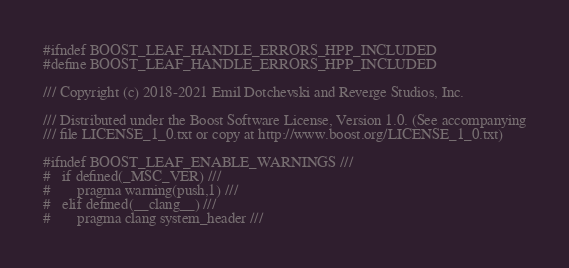Convert code to text. <code><loc_0><loc_0><loc_500><loc_500><_C++_>#ifndef BOOST_LEAF_HANDLE_ERRORS_HPP_INCLUDED
#define BOOST_LEAF_HANDLE_ERRORS_HPP_INCLUDED

/// Copyright (c) 2018-2021 Emil Dotchevski and Reverge Studios, Inc.

/// Distributed under the Boost Software License, Version 1.0. (See accompanying
/// file LICENSE_1_0.txt or copy at http://www.boost.org/LICENSE_1_0.txt)

#ifndef BOOST_LEAF_ENABLE_WARNINGS ///
#   if defined(_MSC_VER) ///
#       pragma warning(push,1) ///
#   elif defined(__clang__) ///
#       pragma clang system_header ///</code> 